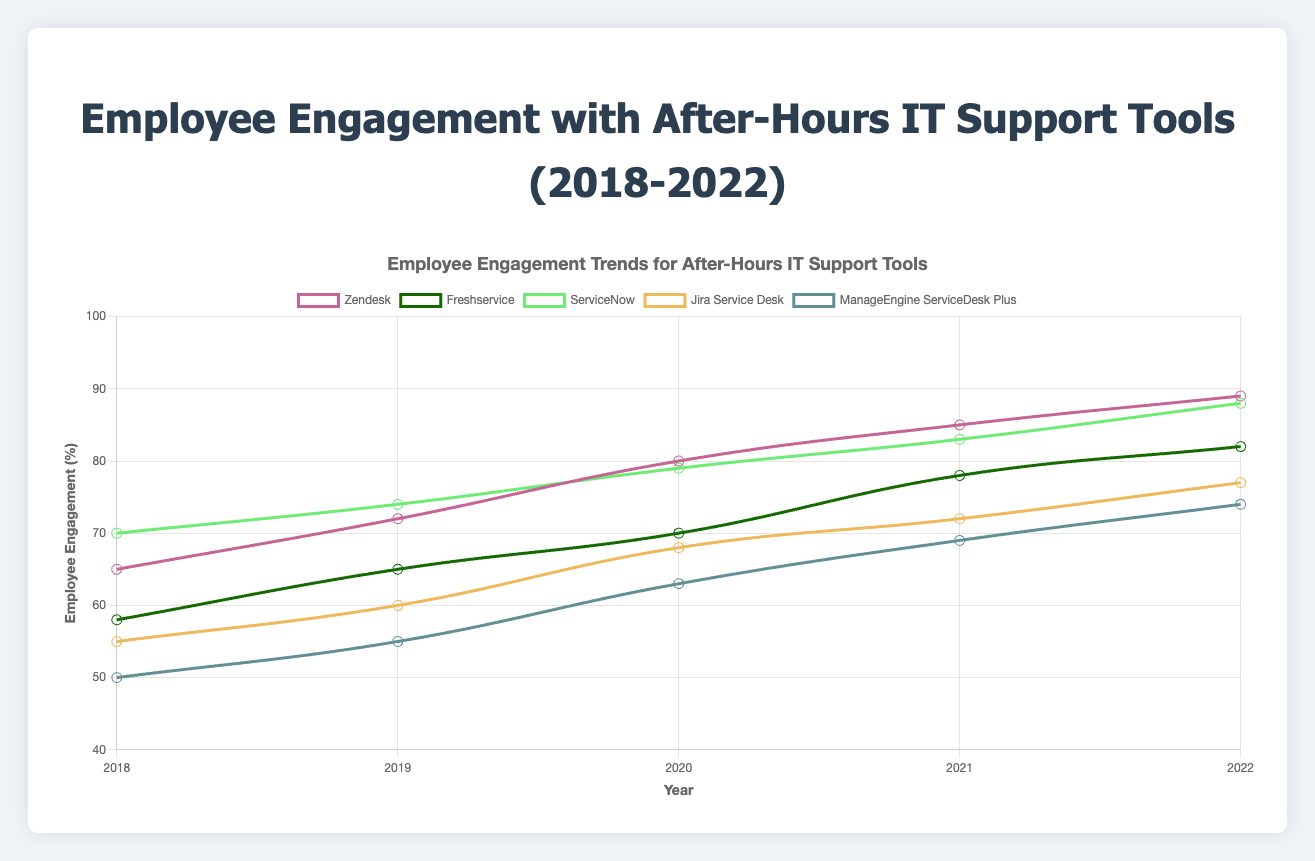Which IT support tool had the highest employee engagement in 2022? The figure shows multiple lines representing different IT support tools. By looking at the highest percentage value reached in 2022, we can see that Zendesk leads with 89%.
Answer: Zendesk Which tool showed the most significant increase in engagement from 2018 to 2022? To determine this, we need to calculate the increase for each tool by subtracting the 2018 engagement from the 2022 engagement:
- Zendesk: 89 - 65 = 24
- Freshservice: 82 - 58 = 24
- ServiceNow: 88 - 70 = 18
- Jira Service Desk: 77 - 55 = 22
- ManageEngine ServiceDesk Plus: 74 - 50 = 24
Thus, Zendesk, Freshservice, and ManageEngine ServiceDesk Plus all show the greatest increase, each with 24%.
Answer: Zendesk, Freshservice, ManageEngine ServiceDesk Plus Which tool had lower engagement in 2020 than in 2019? By observing the data points for 2019 and 2020, we see that none of the tools had lower engagement in 2020 compared to 2019. All show an increase.
Answer: None What was the average engagement level for ServiceNow across all five years? To find the average, sum the engagement levels from 2018 to 2022 for ServiceNow and divide by 5:
(70 + 74 + 79 + 83 + 88) / 5 = 394 / 5 = 78.8
Answer: 78.8 Which year saw the highest overall improvement in engagement across all tools? To determine this, calculate the year-over-year changes and sum them for each year:
- From 2018 to 2019:
  - Zendesk: 72 - 65 = 7
  - Freshservice: 65 - 58 = 7
  - ServiceNow: 74 - 70 = 4
  - Jira Service Desk: 60 - 55 = 5
  - ManageEngine ServiceDesk Plus: 55 - 50 = 5
  Sum: 7 + 7 + 4 + 5 + 5 = 28
- From 2019 to 2020:
  - Zendesk: 80 - 72 = 8
  - Freshservice: 70 - 65 = 5
  - ServiceNow: 79 - 74 = 5
  - Jira Service Desk: 68 - 60 = 8
  - ManageEngine ServiceDesk Plus: 63 - 55 = 8
  Sum: 8 + 5 + 5 + 8 + 8 = 34
- From 2020 to 2021:
  - Zendesk: 85 - 80 = 5
  - Freshservice: 78 - 70 = 8
  - ServiceNow: 83 - 79 = 4
  - Jira Service Desk: 72 - 68 = 4
  - ManageEngine ServiceDesk Plus: 69 - 63 = 6
  Sum: 5 + 8 + 4 + 4 + 6 = 27
- From 2021 to 2022:
  - Zendesk: 89 - 85 = 4
  - Freshservice: 82 - 78 = 4
  - ServiceNow: 88 - 83 = 5
  - Jira Service Desk: 77 - 72 = 5
  - ManageEngine ServiceDesk Plus: 74 - 69 = 5
  Sum: 4 + 4 + 5 + 5 + 5 = 23
Thus, the highest overall improvement was from 2019 to 2020 with a sum of 34.
Answer: 2019 to 2020 What is the combined employee engagement for Zendesk and Freshservice in 2021? Specifically for 2021, add the engagement levels for Zendesk and Freshservice:
Zendesk: 85
Freshservice: 78
Combined: 85 + 78 = 163
Answer: 163 For which tool is the visual trend line most consistently upward without any dips? Observing the lines for any downward slopes or dips, the Zendesk line shows a consistent upward trend without dips from 2018 to 2022.
Answer: Zendesk 